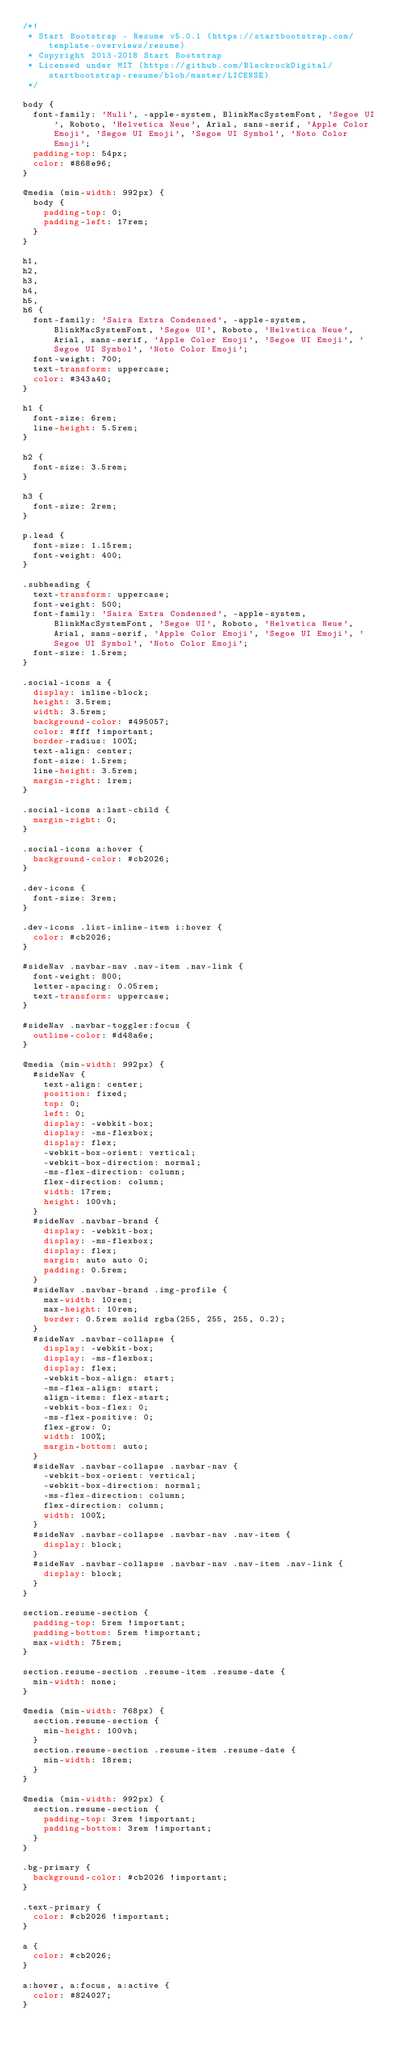<code> <loc_0><loc_0><loc_500><loc_500><_CSS_>/*!
 * Start Bootstrap - Resume v5.0.1 (https://startbootstrap.com/template-overviews/resume)
 * Copyright 2013-2018 Start Bootstrap
 * Licensed under MIT (https://github.com/BlackrockDigital/startbootstrap-resume/blob/master/LICENSE)
 */

body {
  font-family: 'Muli', -apple-system, BlinkMacSystemFont, 'Segoe UI', Roboto, 'Helvetica Neue', Arial, sans-serif, 'Apple Color Emoji', 'Segoe UI Emoji', 'Segoe UI Symbol', 'Noto Color Emoji';
  padding-top: 54px;
  color: #868e96;
}

@media (min-width: 992px) {
  body {
    padding-top: 0;
    padding-left: 17rem;
  }
}

h1,
h2,
h3,
h4,
h5,
h6 {
  font-family: 'Saira Extra Condensed', -apple-system, BlinkMacSystemFont, 'Segoe UI', Roboto, 'Helvetica Neue', Arial, sans-serif, 'Apple Color Emoji', 'Segoe UI Emoji', 'Segoe UI Symbol', 'Noto Color Emoji';
  font-weight: 700;
  text-transform: uppercase;
  color: #343a40;
}

h1 {
  font-size: 6rem;
  line-height: 5.5rem;
}

h2 {
  font-size: 3.5rem;
}

h3 {
  font-size: 2rem;
}

p.lead {
  font-size: 1.15rem;
  font-weight: 400;
}

.subheading {
  text-transform: uppercase;
  font-weight: 500;
  font-family: 'Saira Extra Condensed', -apple-system, BlinkMacSystemFont, 'Segoe UI', Roboto, 'Helvetica Neue', Arial, sans-serif, 'Apple Color Emoji', 'Segoe UI Emoji', 'Segoe UI Symbol', 'Noto Color Emoji';
  font-size: 1.5rem;
}

.social-icons a {
  display: inline-block;
  height: 3.5rem;
  width: 3.5rem;
  background-color: #495057;
  color: #fff !important;
  border-radius: 100%;
  text-align: center;
  font-size: 1.5rem;
  line-height: 3.5rem;
  margin-right: 1rem;
}

.social-icons a:last-child {
  margin-right: 0;
}

.social-icons a:hover {
  background-color: #cb2026;
}

.dev-icons {
  font-size: 3rem;
}

.dev-icons .list-inline-item i:hover {
  color: #cb2026;
}

#sideNav .navbar-nav .nav-item .nav-link {
  font-weight: 800;
  letter-spacing: 0.05rem;
  text-transform: uppercase;
}

#sideNav .navbar-toggler:focus {
  outline-color: #d48a6e;
}

@media (min-width: 992px) {
  #sideNav {
    text-align: center;
    position: fixed;
    top: 0;
    left: 0;
    display: -webkit-box;
    display: -ms-flexbox;
    display: flex;
    -webkit-box-orient: vertical;
    -webkit-box-direction: normal;
    -ms-flex-direction: column;
    flex-direction: column;
    width: 17rem;
    height: 100vh;
  }
  #sideNav .navbar-brand {
    display: -webkit-box;
    display: -ms-flexbox;
    display: flex;
    margin: auto auto 0;
    padding: 0.5rem;
  }
  #sideNav .navbar-brand .img-profile {
    max-width: 10rem;
    max-height: 10rem;
    border: 0.5rem solid rgba(255, 255, 255, 0.2);
  }
  #sideNav .navbar-collapse {
    display: -webkit-box;
    display: -ms-flexbox;
    display: flex;
    -webkit-box-align: start;
    -ms-flex-align: start;
    align-items: flex-start;
    -webkit-box-flex: 0;
    -ms-flex-positive: 0;
    flex-grow: 0;
    width: 100%;
    margin-bottom: auto;
  }
  #sideNav .navbar-collapse .navbar-nav {
    -webkit-box-orient: vertical;
    -webkit-box-direction: normal;
    -ms-flex-direction: column;
    flex-direction: column;
    width: 100%;
  }
  #sideNav .navbar-collapse .navbar-nav .nav-item {
    display: block;
  }
  #sideNav .navbar-collapse .navbar-nav .nav-item .nav-link {
    display: block;
  }
}

section.resume-section {
  padding-top: 5rem !important;
  padding-bottom: 5rem !important;
  max-width: 75rem;
}

section.resume-section .resume-item .resume-date {
  min-width: none;
}

@media (min-width: 768px) {
  section.resume-section {
    min-height: 100vh;
  }
  section.resume-section .resume-item .resume-date {
    min-width: 18rem;
  }
}

@media (min-width: 992px) {
  section.resume-section {
    padding-top: 3rem !important;
    padding-bottom: 3rem !important;
  }
}

.bg-primary {
  background-color: #cb2026 !important;
}

.text-primary {
  color: #cb2026 !important;
}

a {
  color: #cb2026;
}

a:hover, a:focus, a:active {
  color: #824027;
}
</code> 